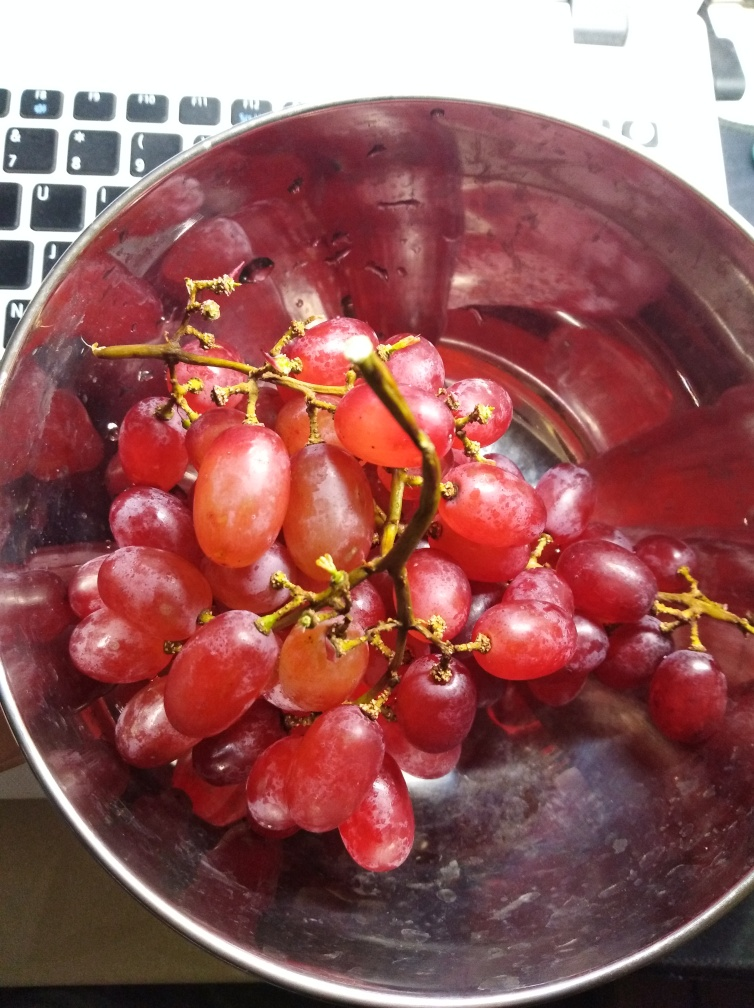Are the texture details of the grapes completely lost? No, the texture details of the grapes are not completely lost. The image shows the individual grapes with visible translucency and some reflections of light on their surfaces, which indicate their moist, juicy texture. The various shades of purple and the delicate hints of green near the stems can also be observed, though the image's lighting and focus cause some details to be less pronounced. 